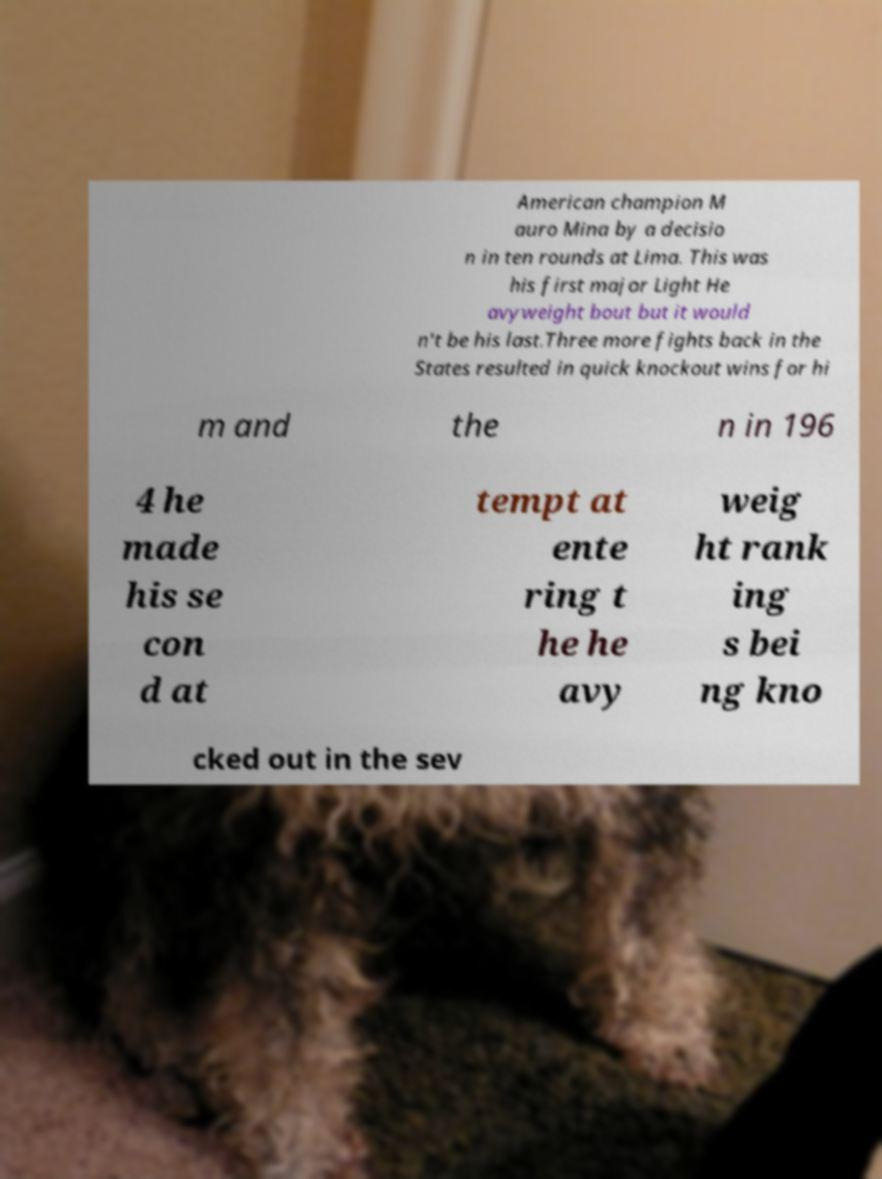Please identify and transcribe the text found in this image. American champion M auro Mina by a decisio n in ten rounds at Lima. This was his first major Light He avyweight bout but it would n't be his last.Three more fights back in the States resulted in quick knockout wins for hi m and the n in 196 4 he made his se con d at tempt at ente ring t he he avy weig ht rank ing s bei ng kno cked out in the sev 